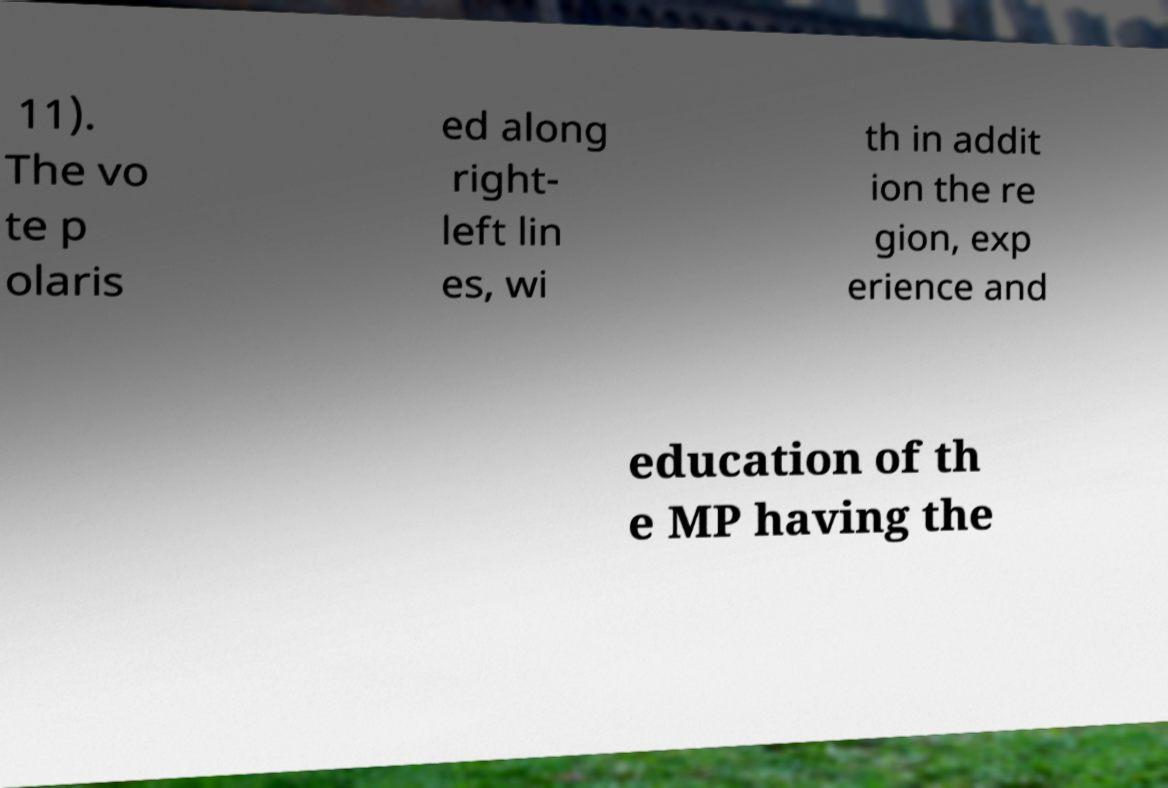There's text embedded in this image that I need extracted. Can you transcribe it verbatim? 11). The vo te p olaris ed along right- left lin es, wi th in addit ion the re gion, exp erience and education of th e MP having the 